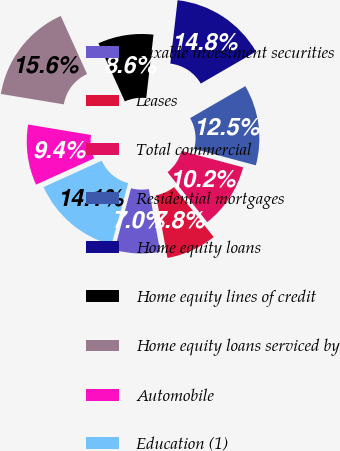Convert chart. <chart><loc_0><loc_0><loc_500><loc_500><pie_chart><fcel>Taxable investment securities<fcel>Leases<fcel>Total commercial<fcel>Residential mortgages<fcel>Home equity loans<fcel>Home equity lines of credit<fcel>Home equity loans serviced by<fcel>Automobile<fcel>Education (1)<nl><fcel>7.04%<fcel>7.82%<fcel>10.16%<fcel>12.5%<fcel>14.83%<fcel>8.6%<fcel>15.61%<fcel>9.38%<fcel>14.06%<nl></chart> 